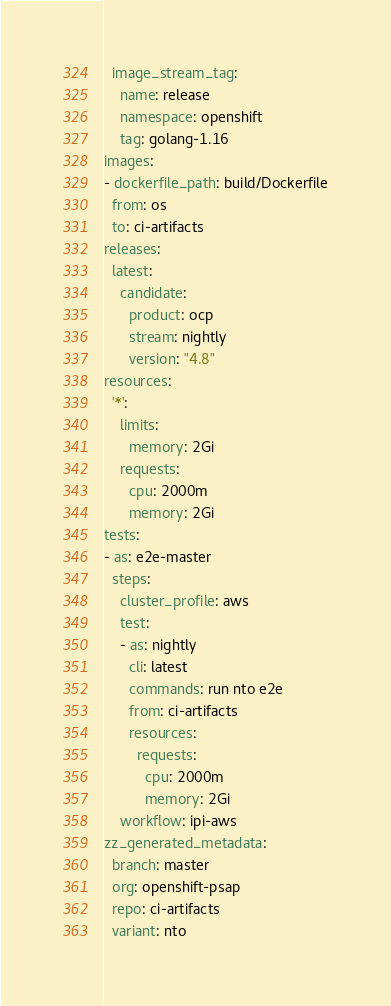<code> <loc_0><loc_0><loc_500><loc_500><_YAML_>  image_stream_tag:
    name: release
    namespace: openshift
    tag: golang-1.16
images:
- dockerfile_path: build/Dockerfile
  from: os
  to: ci-artifacts
releases:
  latest:
    candidate:
      product: ocp
      stream: nightly
      version: "4.8"
resources:
  '*':
    limits:
      memory: 2Gi
    requests:
      cpu: 2000m
      memory: 2Gi
tests:
- as: e2e-master
  steps:
    cluster_profile: aws
    test:
    - as: nightly
      cli: latest
      commands: run nto e2e
      from: ci-artifacts
      resources:
        requests:
          cpu: 2000m
          memory: 2Gi
    workflow: ipi-aws
zz_generated_metadata:
  branch: master
  org: openshift-psap
  repo: ci-artifacts
  variant: nto
</code> 